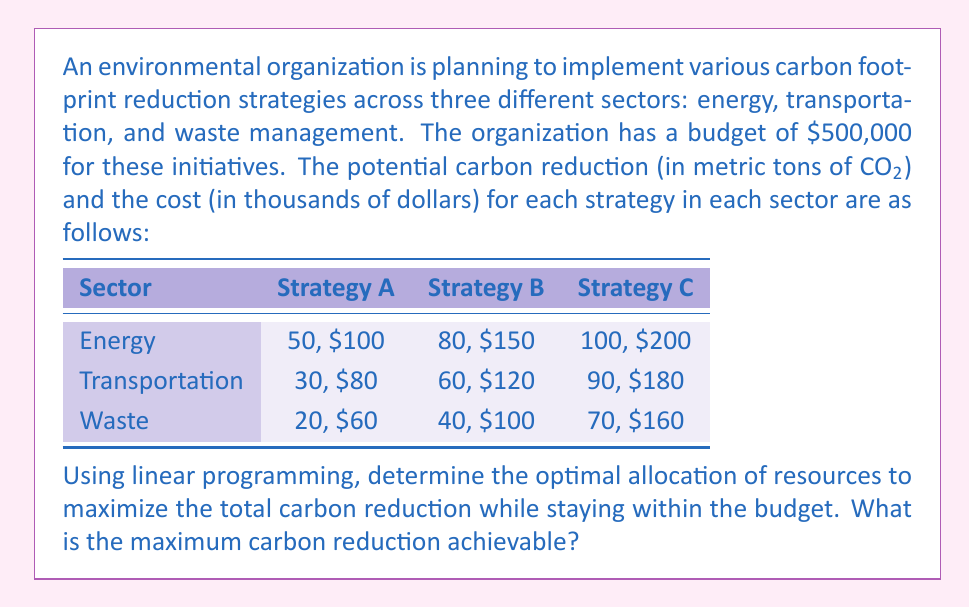Provide a solution to this math problem. To solve this problem using linear programming, we need to:

1. Define the decision variables
2. Formulate the objective function
3. Set up the constraints
4. Solve the linear programming problem

Step 1: Define the decision variables

Let $x_{ij}$ represent the fraction of strategy $j$ implemented in sector $i$, where $i \in \{E, T, W\}$ (Energy, Transportation, Waste) and $j \in \{A, B, C\}$.

Step 2: Formulate the objective function

The objective is to maximize the total carbon reduction:

$$\text{Maximize } Z = 50x_{EA} + 80x_{EB} + 100x_{EC} + 30x_{TA} + 60x_{TB} + 90x_{TC} + 20x_{WA} + 40x_{WB} + 70x_{WC}$$

Step 3: Set up the constraints

Budget constraint:
$$100x_{EA} + 150x_{EB} + 200x_{EC} + 80x_{TA} + 120x_{TB} + 180x_{TC} + 60x_{WA} + 100x_{WB} + 160x_{WC} \leq 500$$

Implementation constraints for each sector:
$$x_{EA} + x_{EB} + x_{EC} \leq 1$$
$$x_{TA} + x_{TB} + x_{TC} \leq 1$$
$$x_{WA} + x_{WB} + x_{WC} \leq 1$$

Non-negativity constraints:
$$x_{ij} \geq 0 \text{ for all } i \text{ and } j$$

Step 4: Solve the linear programming problem

Using a linear programming solver (e.g., simplex method), we obtain the following optimal solution:

$$x_{EC} = 1, x_{TB} = 1, x_{WB} = 1$$
$$\text{All other } x_{ij} = 0$$

This means we should fully implement Strategy C in the Energy sector, Strategy B in the Transportation sector, and Strategy B in the Waste sector.

The maximum carbon reduction achieved is:
$$Z = 100 + 60 + 40 = 200 \text{ metric tons of CO}_2$$

The total cost is:
$$200 + 120 + 100 = 420 \text{ thousand dollars}$$

This solution satisfies the budget constraint and maximizes the carbon reduction.
Answer: The maximum carbon reduction achievable is 200 metric tons of CO2. 